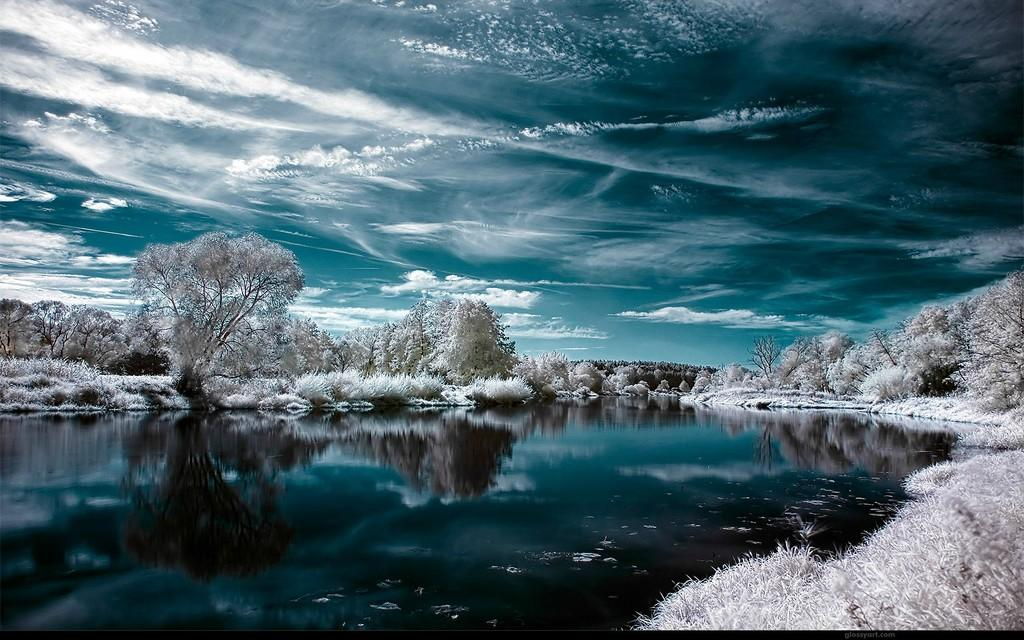What type of natural feature is present in the image? There is a water body in the image. What other natural elements can be seen in the image? There are plants and a group of trees in the image. What is visible in the background of the image? The sky is visible in the image. How would you describe the weather based on the sky in the image? The sky appears to be cloudy in the image. What type of button can be seen on the water body in the image? There is no button present on the water body in the image. Which flower is growing near the group of trees in the image? There is no flower mentioned or visible in the image. 